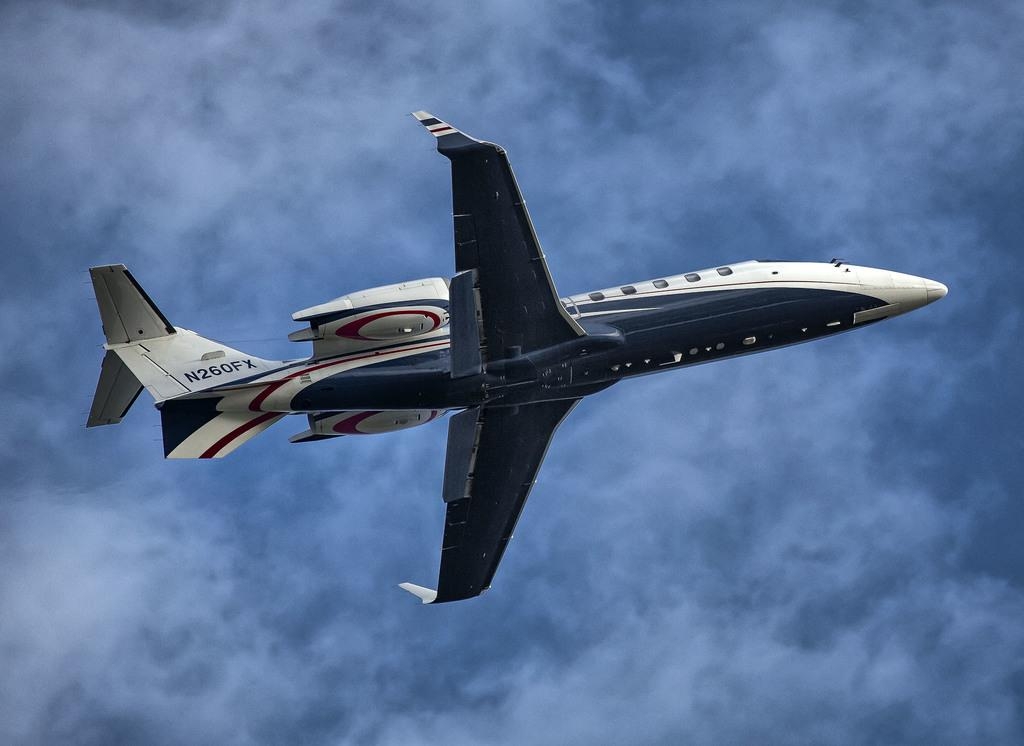What is the main subject in the center of the image? There is an airplane in the center of the image. What can be seen in the background of the image? There is sky visible in the background of the image. Can you see any cushions on the street in the image? There is no street or cushion present in the image; it features an airplane and sky. 